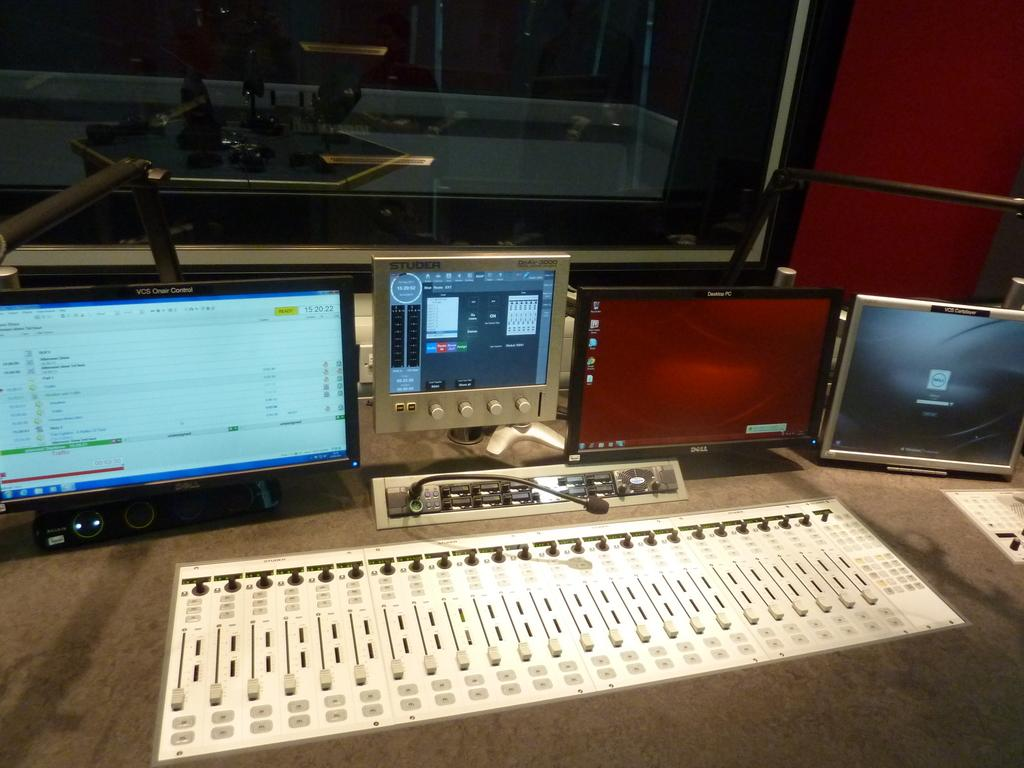<image>
Give a short and clear explanation of the subsequent image. A small VCS screen has the time of 15:20:22 in the upper right corner. 